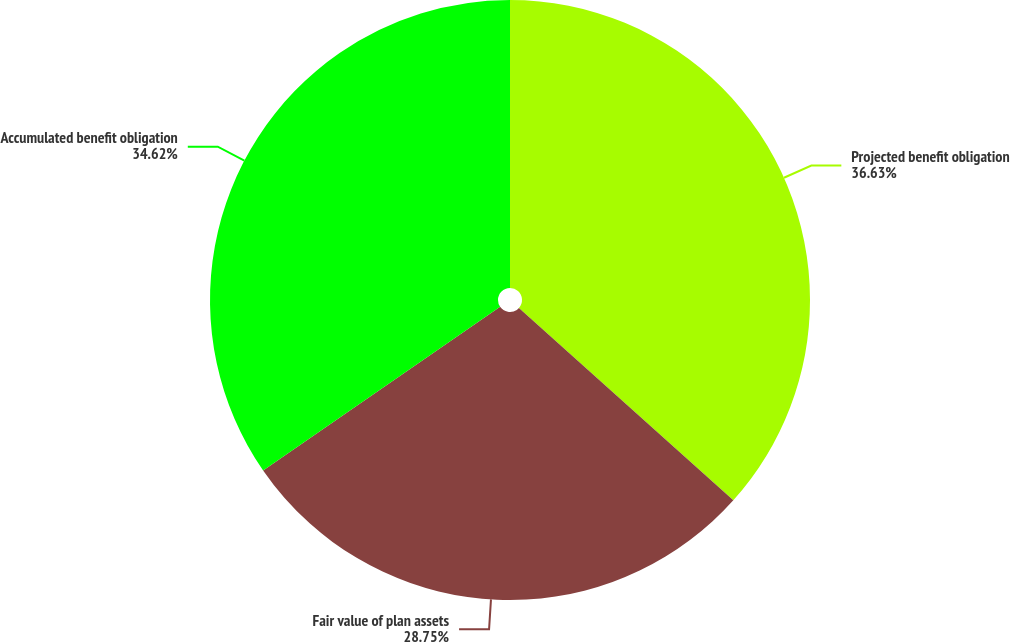Convert chart to OTSL. <chart><loc_0><loc_0><loc_500><loc_500><pie_chart><fcel>Projected benefit obligation<fcel>Fair value of plan assets<fcel>Accumulated benefit obligation<nl><fcel>36.64%<fcel>28.75%<fcel>34.62%<nl></chart> 